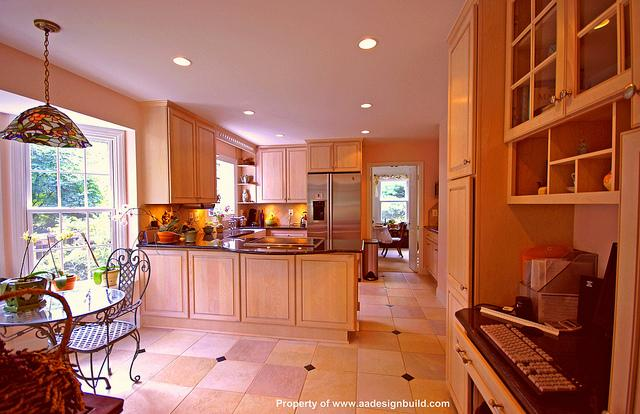What shape is the black tiles on the floor? diamond 